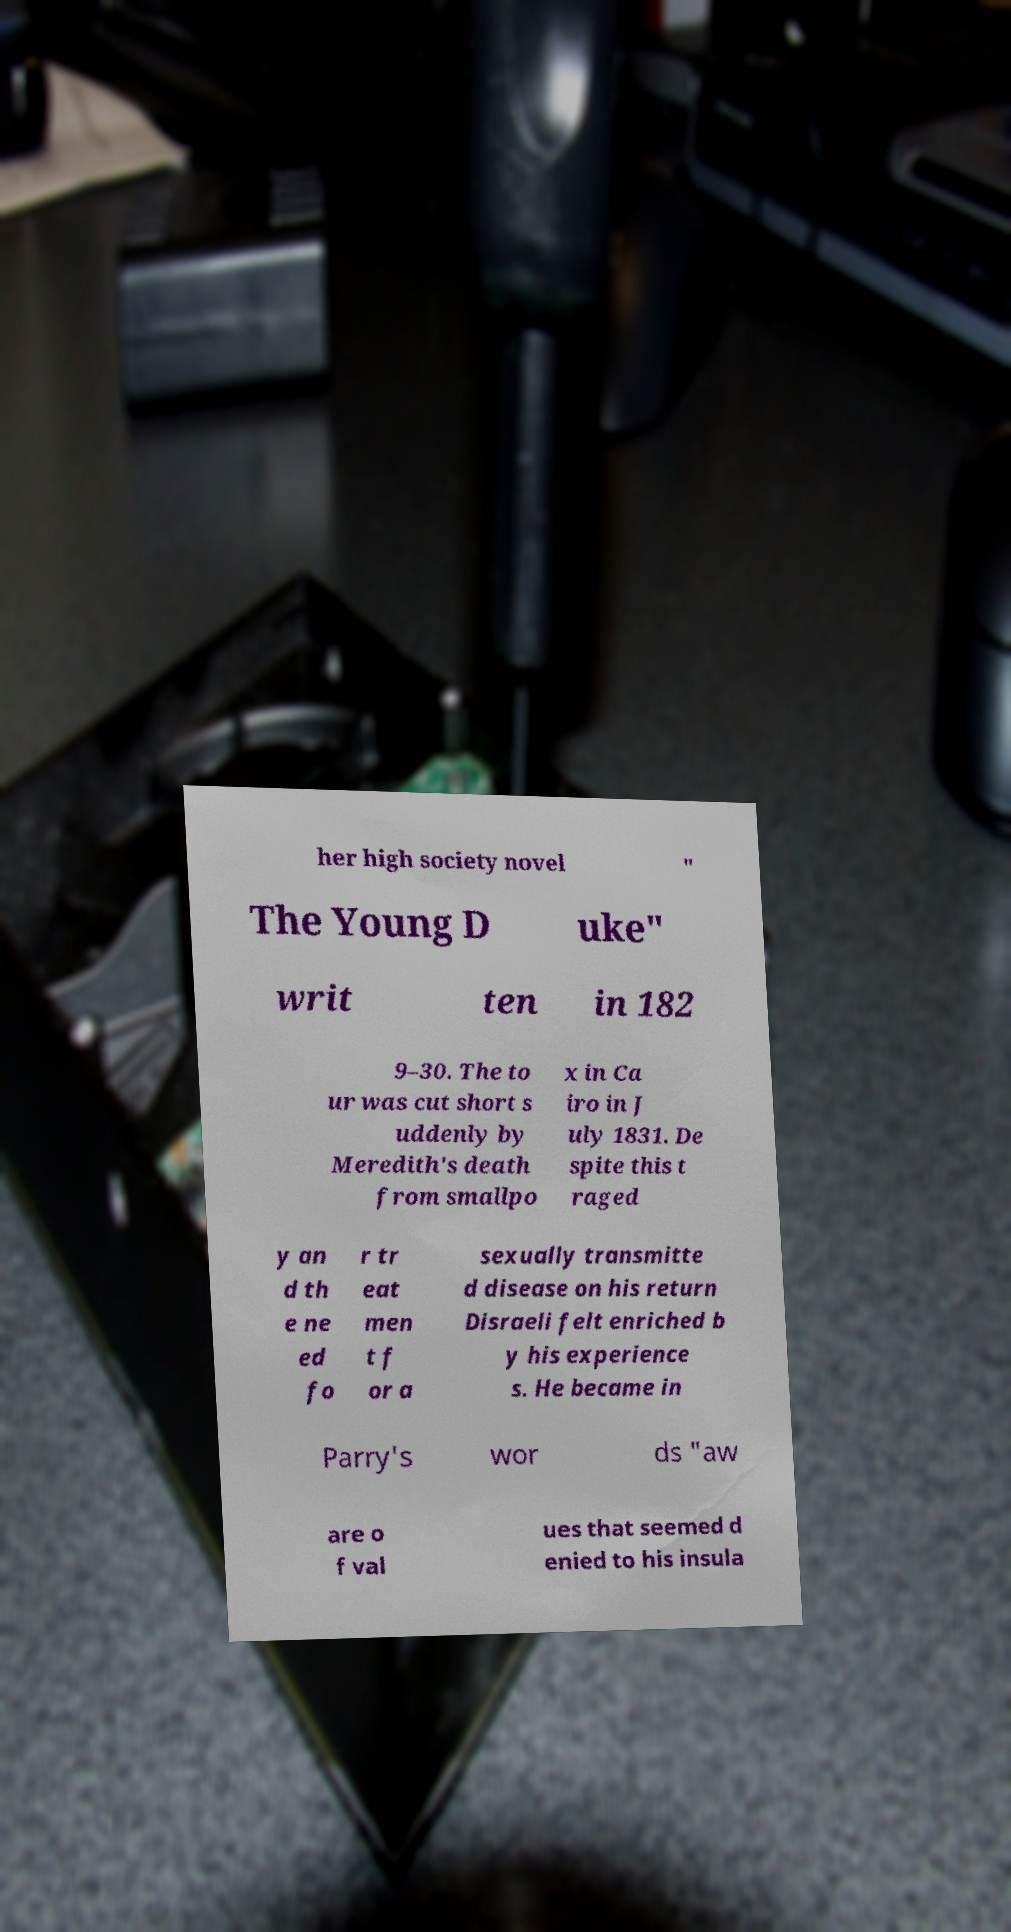Can you read and provide the text displayed in the image?This photo seems to have some interesting text. Can you extract and type it out for me? her high society novel " The Young D uke" writ ten in 182 9–30. The to ur was cut short s uddenly by Meredith's death from smallpo x in Ca iro in J uly 1831. De spite this t raged y an d th e ne ed fo r tr eat men t f or a sexually transmitte d disease on his return Disraeli felt enriched b y his experience s. He became in Parry's wor ds "aw are o f val ues that seemed d enied to his insula 